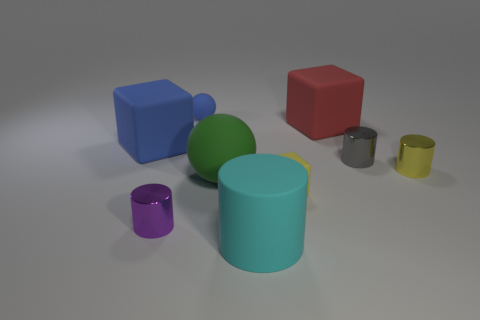How many tiny yellow matte blocks are behind the matte sphere that is behind the cube that is on the left side of the cyan cylinder?
Your response must be concise. 0. There is another matte cube that is the same size as the red rubber cube; what color is it?
Ensure brevity in your answer.  Blue. How many other objects are the same color as the small matte block?
Make the answer very short. 1. Are there more cyan rubber objects on the right side of the red matte cube than brown objects?
Your answer should be very brief. No. Does the large blue thing have the same material as the cyan cylinder?
Your response must be concise. Yes. How many things are either tiny shiny things on the left side of the small blue object or blue matte things?
Make the answer very short. 3. What number of other objects are the same size as the red cube?
Provide a short and direct response. 3. Is the number of red things that are in front of the yellow matte thing the same as the number of tiny yellow blocks to the right of the large red cube?
Your answer should be compact. Yes. There is a small object that is the same shape as the large blue matte object; what color is it?
Your answer should be compact. Yellow. Is there any other thing that is the same shape as the large green matte thing?
Your response must be concise. Yes. 